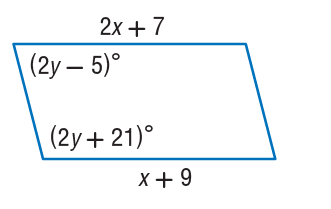Answer the mathemtical geometry problem and directly provide the correct option letter.
Question: Find y so that the quadrilateral is a parallelogram.
Choices: A: 9 B: 20 C: 21 D: 41 D 